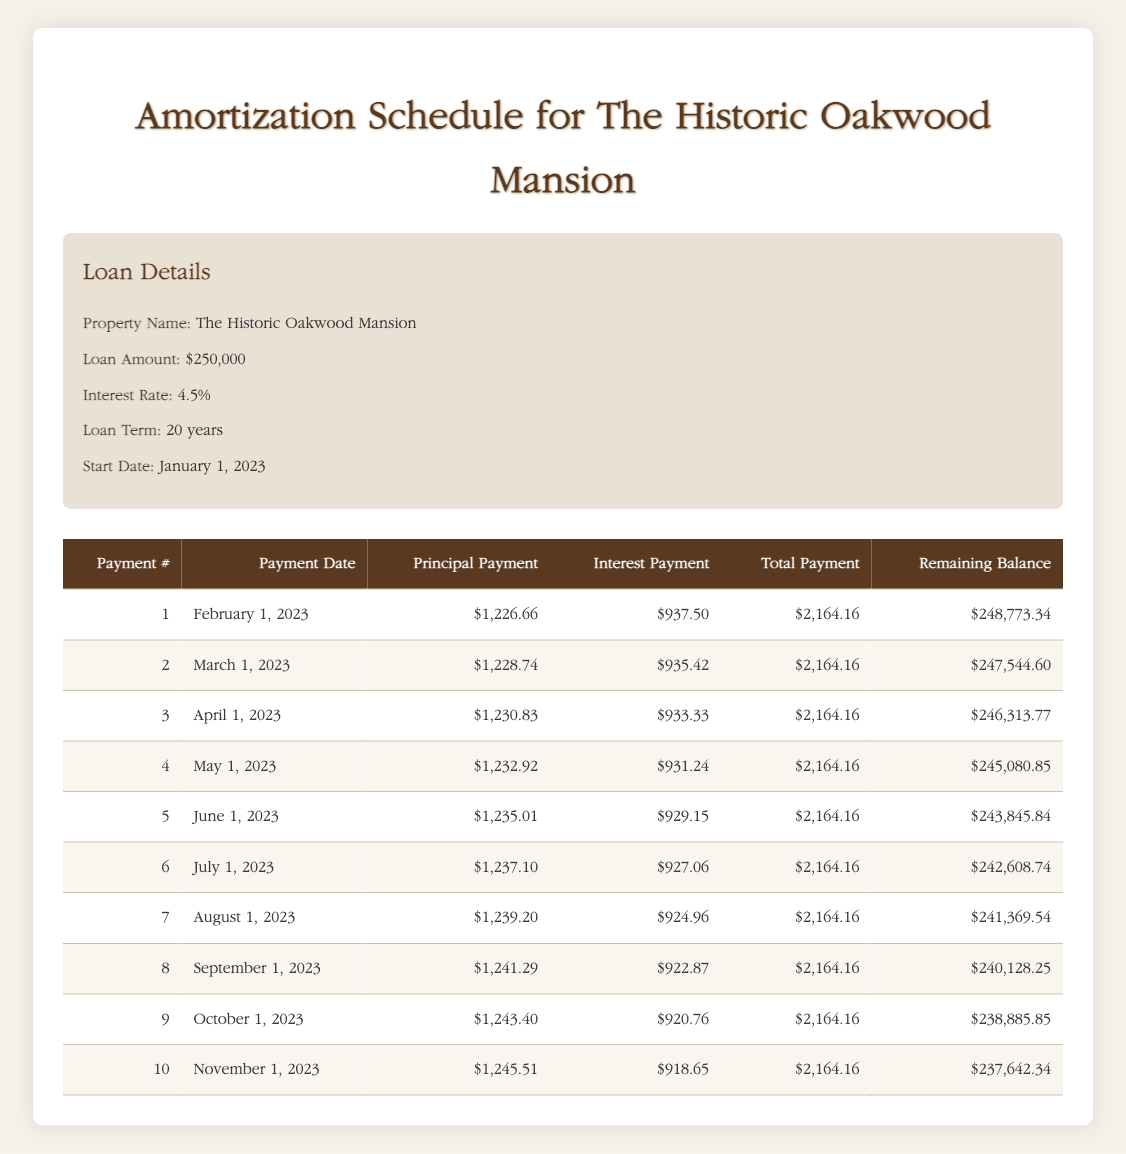What is the interest payment for the first month? The interest payment for the first month is directly listed in the first row of the table, which shows an amount of 937.50
Answer: 937.50 How much is the total payment for the third month? The total payment for the third month is shown in the third row of the table, listed as 2164.16
Answer: 2164.16 What is the remaining balance after the second payment? The remaining balance after the second payment is located in the second row of the table and is 247544.60
Answer: 247544.60 What is the average principal payment over the first three months? To find the average principal payment over the first three months, we add the principal payments for the three months: (1226.66 + 1228.74 + 1230.83) = 3686.23, then divide by 3, which equals 1228.74
Answer: 1228.74 Did the total payment increase from the second month to the third month? By reviewing the total payments for the second and third months, both are noted as 2164.16, so there was no increase
Answer: No What is the difference in interest payment between the first and the tenth month? To find the difference in interest payments between the first month (937.50) and the tenth month (918.65), we subtract the tenth month's payment from the first month's payment: 937.50 - 918.65 = 18.85
Answer: 18.85 How much total principal has been paid off after the first five payments? Adding the principal payments from the first five rows: (1226.66 + 1228.74 + 1230.83 + 1232.92 + 1235.01) = 6144.16
Answer: 6144.16 Is the principal payment for the seventh month greater than 1240? The principal payment for the seventh month is noted as 1239.20, which is less than 1240
Answer: No How much is the remaining balance after the sixth payment compared to the remaining balance after the fourth payment? We look at the remaining balances from the sixth and fourth payments: 242608.74 and 245080.85 respectively. The difference in balances is 245080.85 - 242608.74 = 2472.11
Answer: 2472.11 